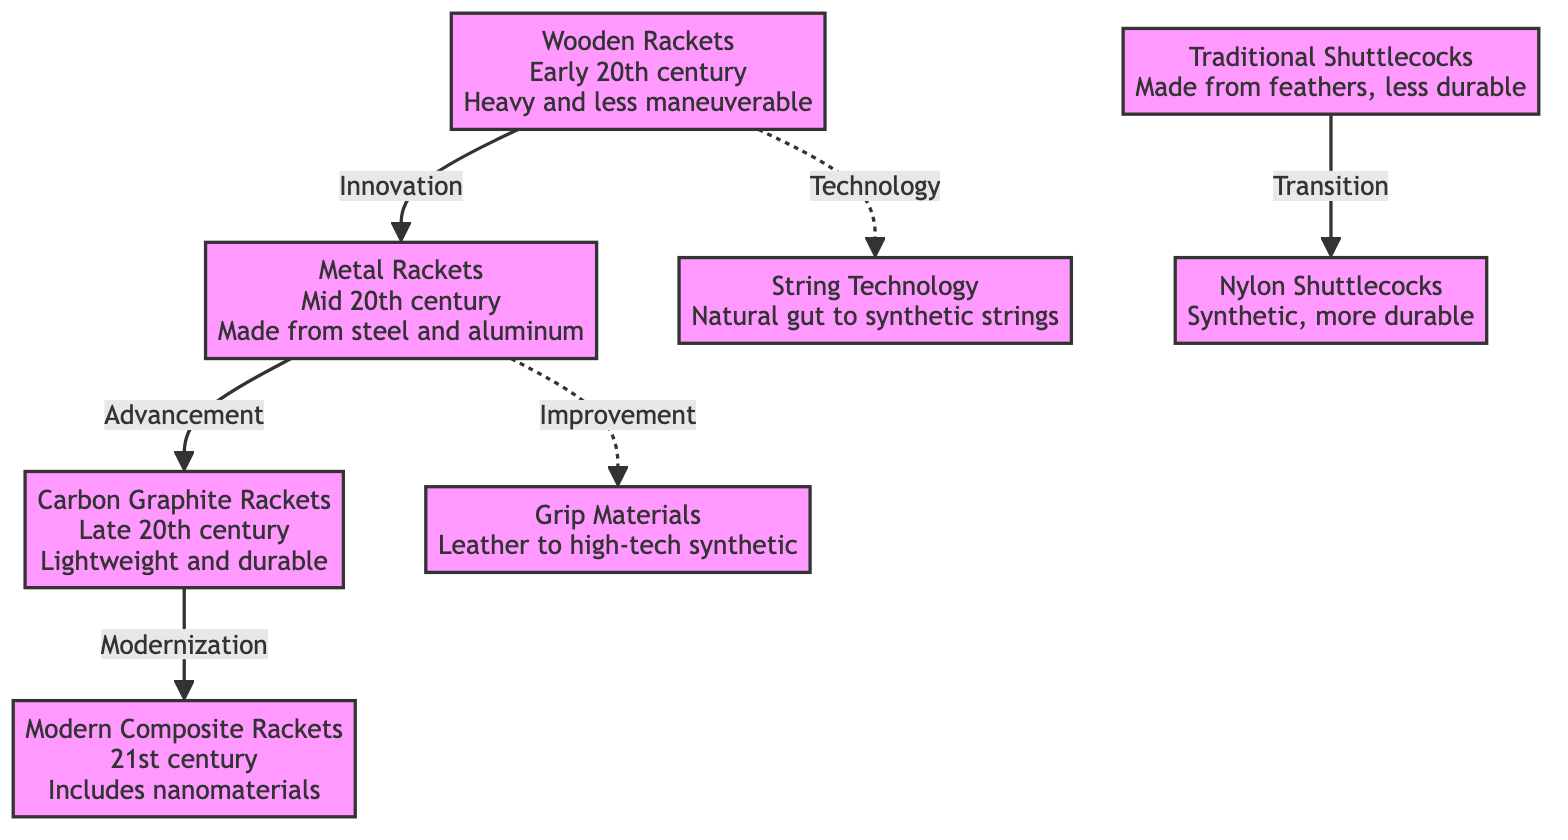What type of rackets were used in the early 20th century? The diagram states that wooden rackets were used in the early 20th century.
Answer: Wooden Rackets Which type of rackets followed wooden rackets in the evolution? The diagram shows that metal rackets came after wooden rackets as an innovation.
Answer: Metal Rackets What was the main material transition in rackets from mid to late 20th century? The transition was from metal (steel and aluminum) to carbon graphite, which is noted as lightweight and durable.
Answer: Carbon Graphite Rackets How many types of shuttlecocks are mentioned in the diagram? The diagram lists two types of shuttlecocks: traditional (feather-made) and nylon (synthetic).
Answer: Two What connects traditional shuttlecocks to nylon shuttlecocks in the diagram? The diagram indicates a transition between traditional shuttlecocks and nylon shuttlecocks.
Answer: Transition What is the relationship between wooden rackets and string technology? The diagram illustrates that wooden rackets have a dashed connection to string technology, indicating a technological link rather than a direct evolution.
Answer: Technology What advancement occurred from metal rackets to carbon graphite rackets? The diagram denotes the advancement from metal rackets to carbon graphite rackets.
Answer: Advancement What is a key feature of modern composite rackets mentioned in the diagram? The diagram mentions that modern composite rackets include nanomaterials, highlighting a key feature of technological advancement.
Answer: Nanomaterials Which material was used for grips before the adoption of high-tech synthetic materials? The diagram indicates that grip materials transitioned from leather to high-tech synthetics, where leather was the earlier material.
Answer: Leather 